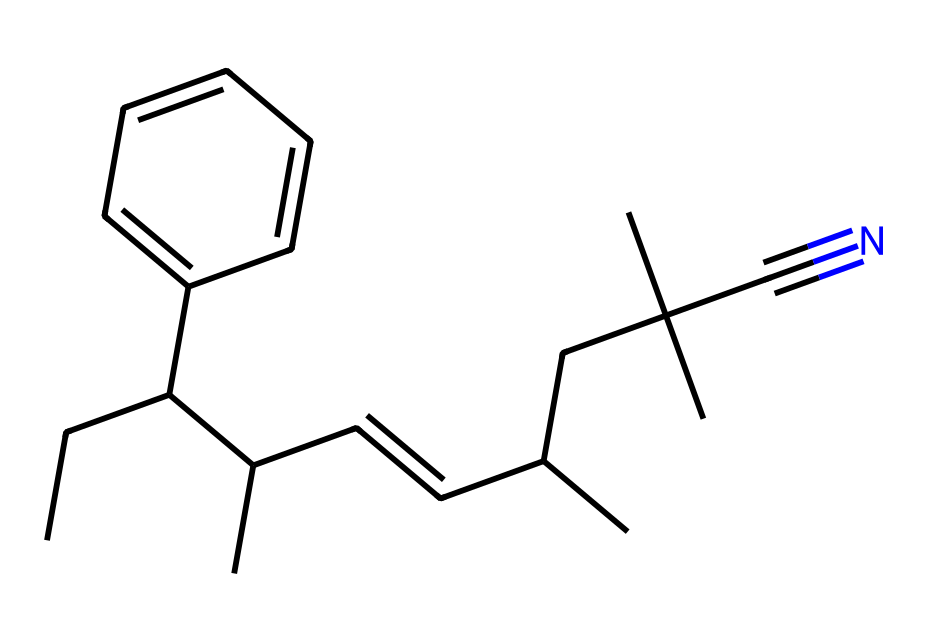What is the chemical name of this compound? The given SMILES representation shows the structure of acrylonitrile butadiene styrene, commonly known as ABS. This is determined by recognizing the functional groups present and linking them to the well-known polymer names.
Answer: acrylonitrile butadiene styrene How many carbon atoms are in the structure? By analyzing the SMILES, we can count the number of 'C' symbols that represent carbon atoms. Each 'C' in the structure corresponds to a carbon atom, totaling to 18 carbon atoms.
Answer: 18 What type of bonds are present in this chemical structure? The SMILES representation indicates double bonds (C=C) and single bonds (C-C) typical of organic compounds. The presence of a carbon-nitrogen triple bond (C#N) is also noted, specifically in the acrylonitrile part.
Answer: double and single bonds; triple bond What functional group is indicated by C#N? The C#N notation indicates a nitrile group (-C≡N), which is characteristic of acrylonitrile. This shows that the compound has a carbon atom triple-bonded to a nitrogen atom, classifying it as a nitrile.
Answer: nitrile What aspect of ABS contributes to its toughness? The rubbery butadiene component provides flexibility and toughness, which contrasts with the more rigid polystyrene and acrylonitrile segments in ABS, thus enhancing the toughness of the final product.
Answer: butadiene What does the presence of phenyl (C6H5) suggest about ABS's properties? The phenyl group increases the aromaticity of the polymer, contributing to its strength and rigidity while also improving thermal stability, which is beneficial for use in model train components.
Answer: strength and rigidity 